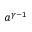<formula> <loc_0><loc_0><loc_500><loc_500>a ^ { \gamma - 1 }</formula> 